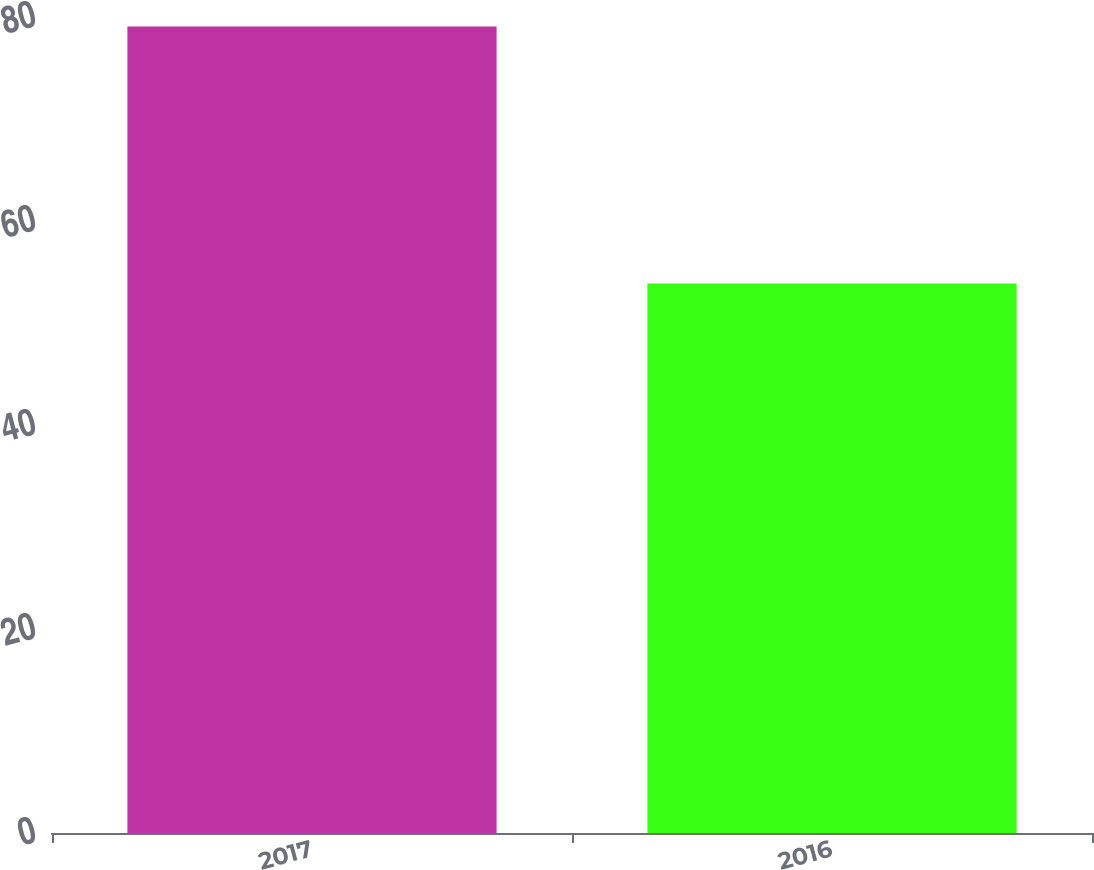<chart> <loc_0><loc_0><loc_500><loc_500><bar_chart><fcel>2017<fcel>2016<nl><fcel>79.06<fcel>53.88<nl></chart> 